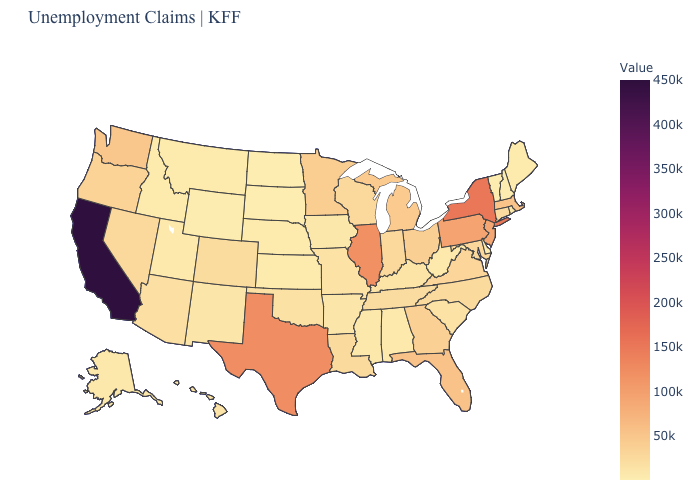Which states have the lowest value in the USA?
Be succinct. South Dakota. Does South Dakota have the lowest value in the MidWest?
Short answer required. Yes. Does California have the highest value in the West?
Answer briefly. Yes. 